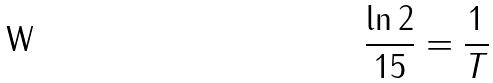Convert formula to latex. <formula><loc_0><loc_0><loc_500><loc_500>\frac { \ln 2 } { 1 5 } = \frac { 1 } { T }</formula> 